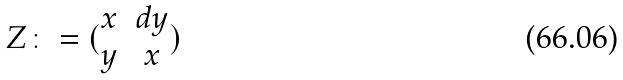Convert formula to latex. <formula><loc_0><loc_0><loc_500><loc_500>Z \colon = ( \begin{matrix} x & d y \\ y & x \end{matrix} )</formula> 